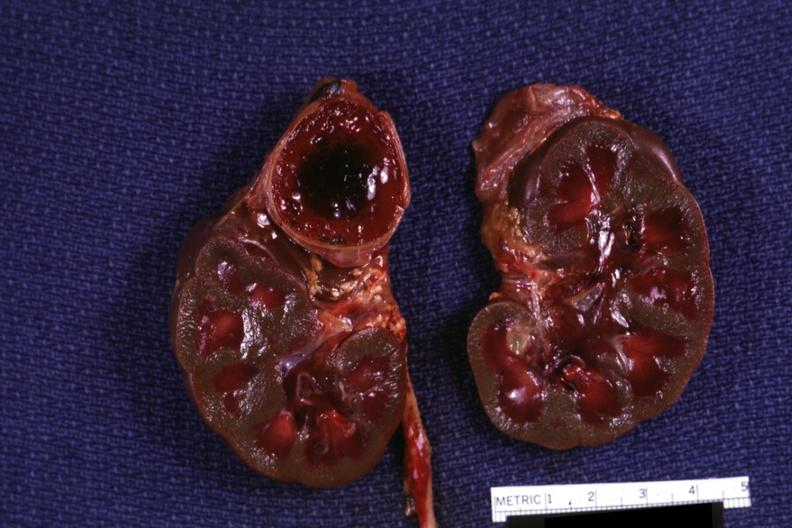what does this image show?
Answer the question using a single word or phrase. Section of both kidneys and adrenals hemorrhage on one side kidneys are jaundiced 